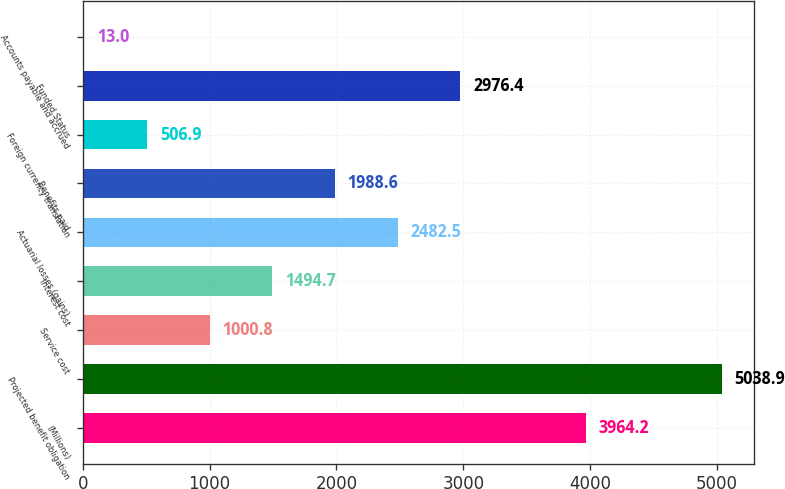Convert chart to OTSL. <chart><loc_0><loc_0><loc_500><loc_500><bar_chart><fcel>(Millions)<fcel>Projected benefit obligation<fcel>Service cost<fcel>Interest cost<fcel>Actuarial losses (gains)<fcel>Benefits paid<fcel>Foreign currency translation<fcel>Funded Status<fcel>Accounts payable and accrued<nl><fcel>3964.2<fcel>5038.9<fcel>1000.8<fcel>1494.7<fcel>2482.5<fcel>1988.6<fcel>506.9<fcel>2976.4<fcel>13<nl></chart> 